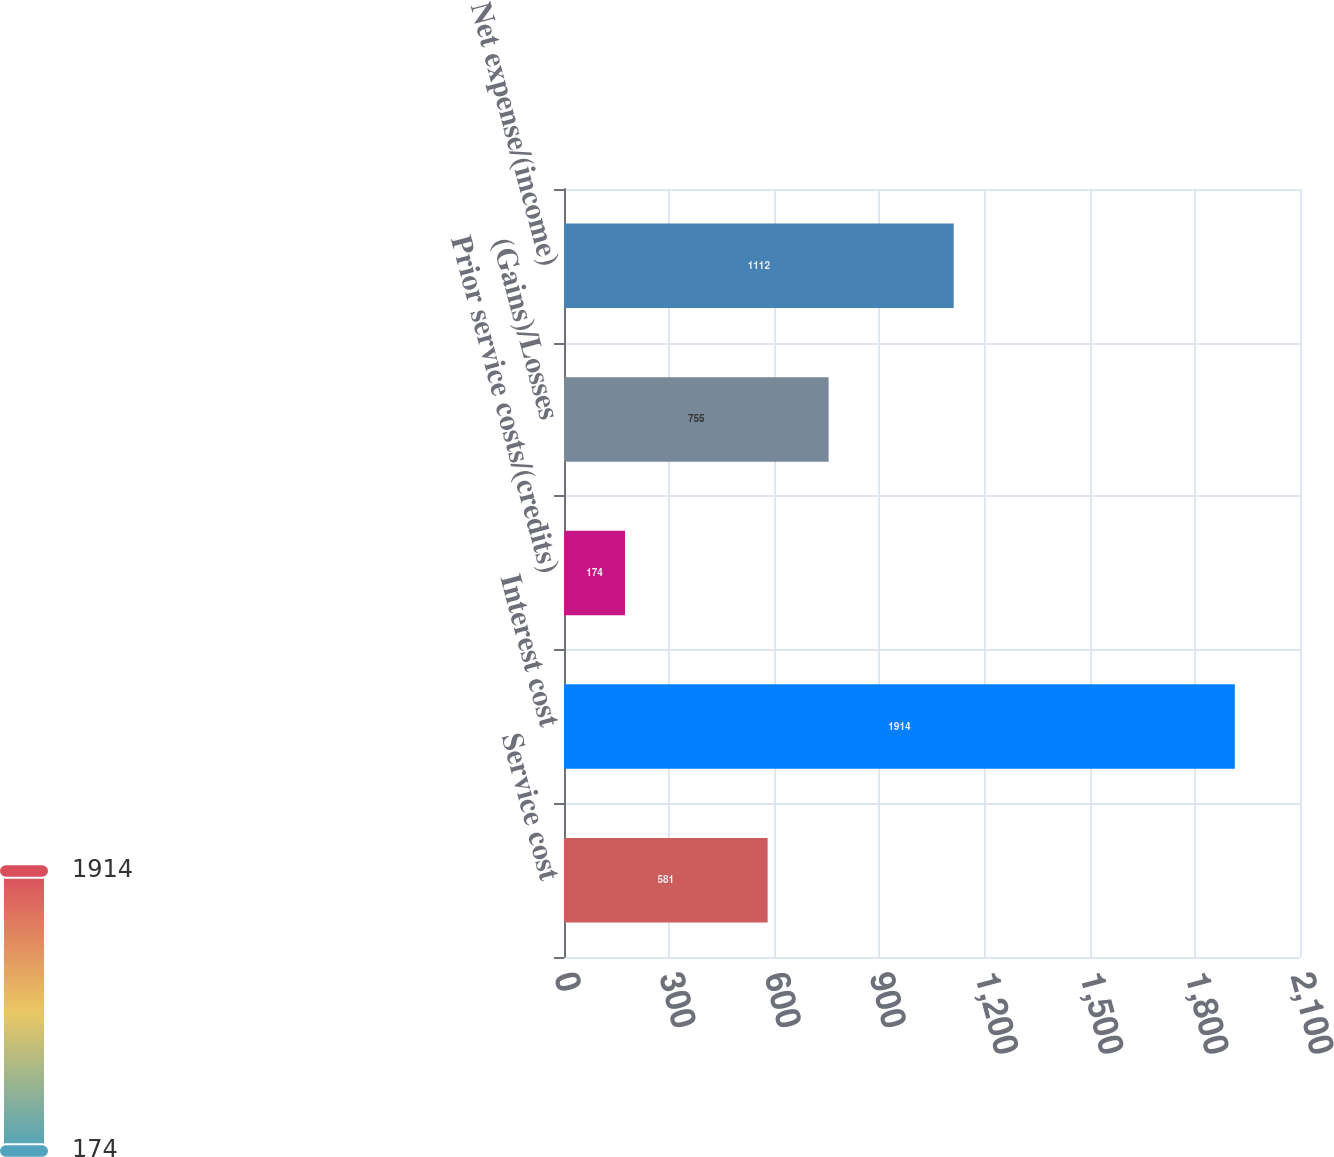Convert chart. <chart><loc_0><loc_0><loc_500><loc_500><bar_chart><fcel>Service cost<fcel>Interest cost<fcel>Prior service costs/(credits)<fcel>(Gains)/Losses<fcel>Net expense/(income)<nl><fcel>581<fcel>1914<fcel>174<fcel>755<fcel>1112<nl></chart> 